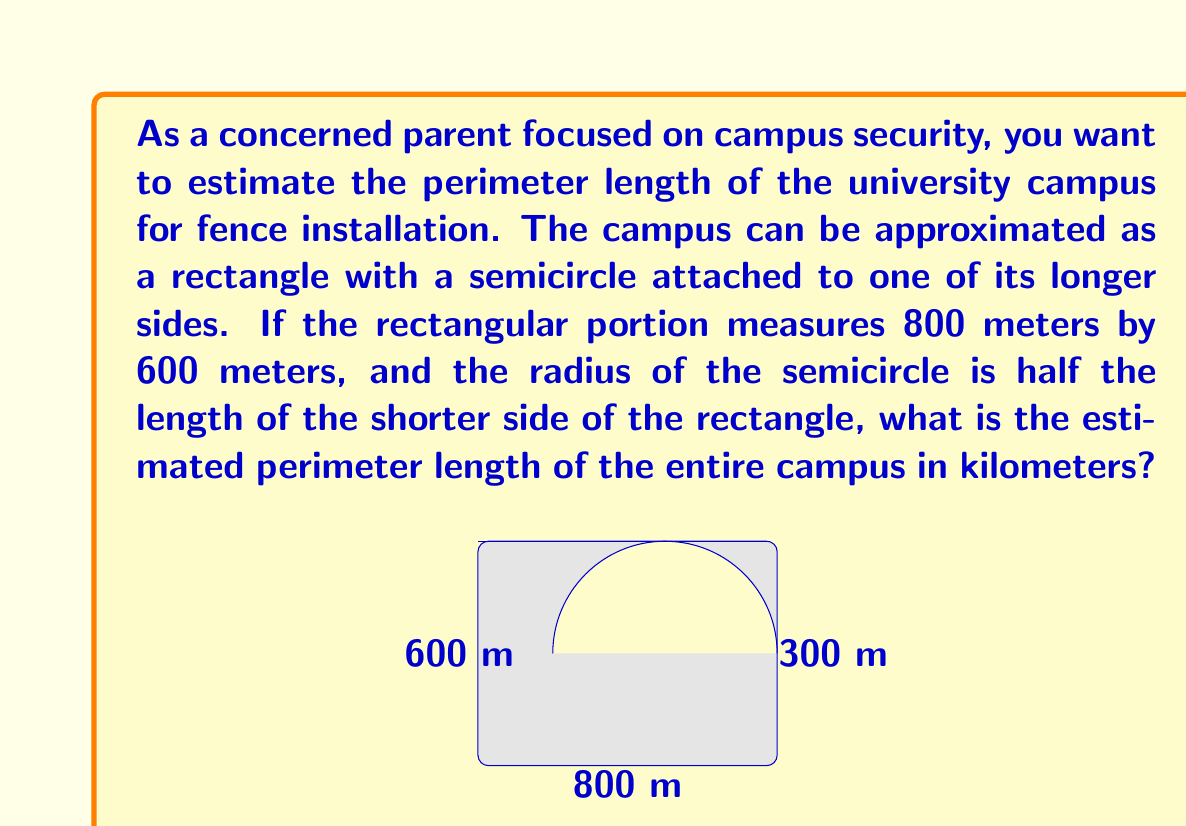Solve this math problem. Let's approach this problem step by step:

1) First, let's identify the known dimensions:
   - Rectangle length: 800 meters
   - Rectangle width: 600 meters
   - Radius of semicircle: 300 meters (half of the shorter side)

2) To calculate the perimeter, we need to add:
   - The lengths of three sides of the rectangle
   - The length of the semicircular arc

3) Calculating the rectangular portion:
   $$ 800 + 600 + 800 = 2200 \text{ meters} $$

4) For the semicircular portion, we need to calculate the arc length:
   The formula for a semicircle's arc length is $\pi r$, where $r$ is the radius.
   $$ \pi \times 300 = 300\pi \text{ meters} $$

5) Now, we can add these together:
   $$ 2200 + 300\pi \text{ meters} $$

6) Simplifying (keeping $\pi$ as is for precision):
   $$ 2200 + 942.48 \approx 3142.48 \text{ meters} $$

7) Converting to kilometers:
   $$ 3142.48 \div 1000 \approx 3.14 \text{ kilometers} $$

Thus, the estimated perimeter length of the entire campus is approximately 3.14 kilometers.
Answer: $3.14 \text{ km}$ (or more precisely, $2200 + 300\pi \text{ meters}$) 